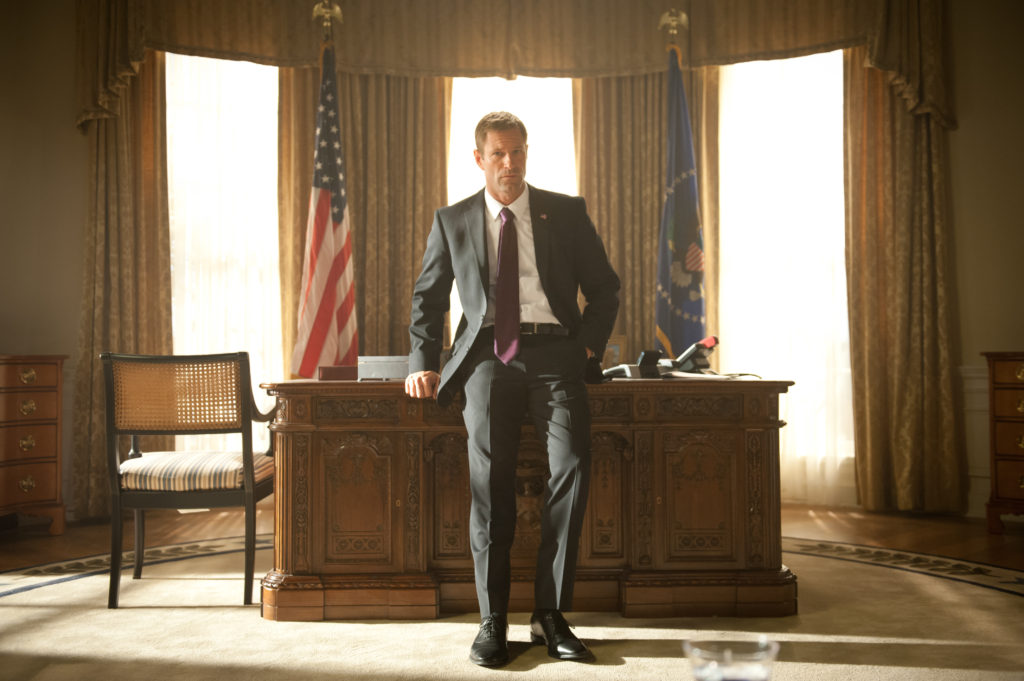Can you imagine a future scenario taking place in this setting? In a near-future scenario, this room might witness the character (President Asher) negotiating an unprecedented peace treaty with an extraterrestrial delegation. The grandeur of the setting remains, but subtle futuristic elements have been integrated – holographic interfaces on the desk and advanced communication panels behind the flags. The room hums with the anticipation of making galactic history as President Asher, alongside his diplomatic team, engages with serene, other-worldly beings. The air is thick with the promise of interstellar cooperation as they discuss ways to share knowledge, technology, and resources for the betterment of all civilizations. This setting, steeped in traditional authority, now plays a pivotal role in ushering humanity into a new era of cosmic unity and exploration. 